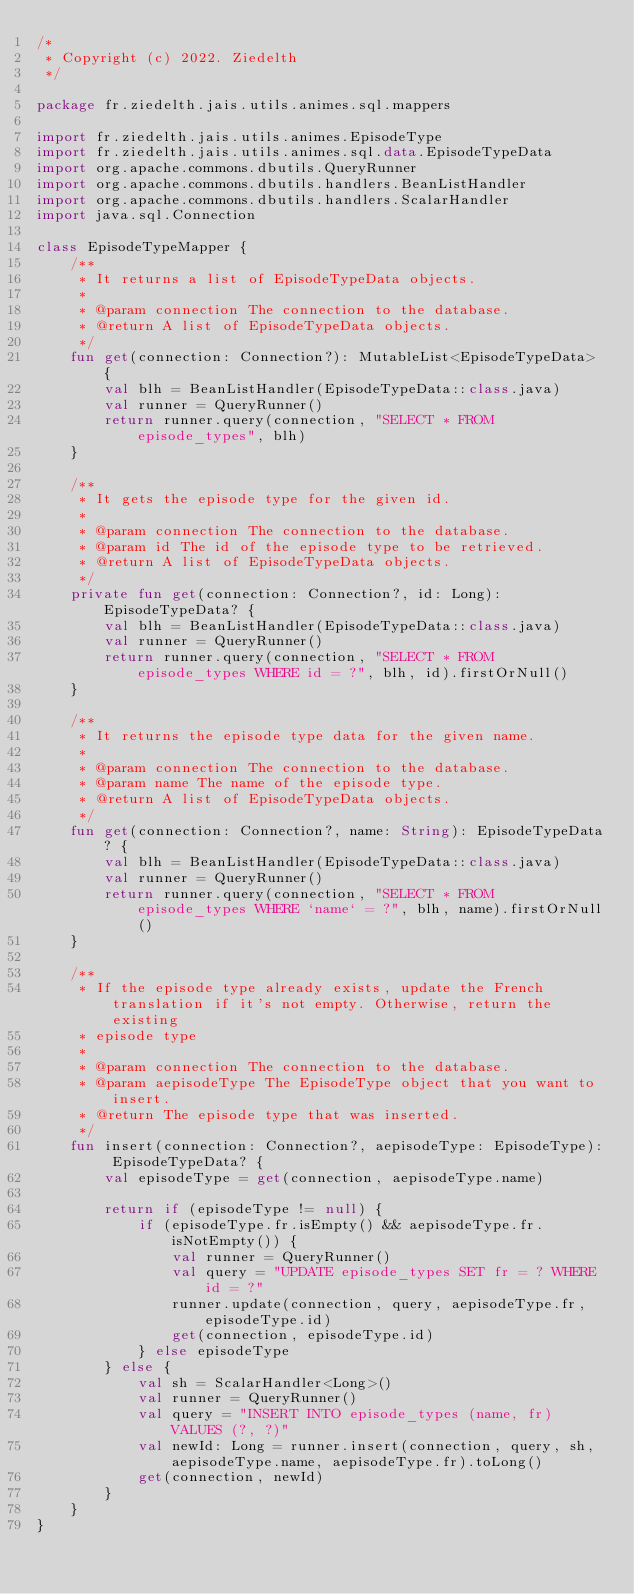Convert code to text. <code><loc_0><loc_0><loc_500><loc_500><_Kotlin_>/*
 * Copyright (c) 2022. Ziedelth
 */

package fr.ziedelth.jais.utils.animes.sql.mappers

import fr.ziedelth.jais.utils.animes.EpisodeType
import fr.ziedelth.jais.utils.animes.sql.data.EpisodeTypeData
import org.apache.commons.dbutils.QueryRunner
import org.apache.commons.dbutils.handlers.BeanListHandler
import org.apache.commons.dbutils.handlers.ScalarHandler
import java.sql.Connection

class EpisodeTypeMapper {
    /**
     * It returns a list of EpisodeTypeData objects.
     *
     * @param connection The connection to the database.
     * @return A list of EpisodeTypeData objects.
     */
    fun get(connection: Connection?): MutableList<EpisodeTypeData> {
        val blh = BeanListHandler(EpisodeTypeData::class.java)
        val runner = QueryRunner()
        return runner.query(connection, "SELECT * FROM episode_types", blh)
    }

    /**
     * It gets the episode type for the given id.
     *
     * @param connection The connection to the database.
     * @param id The id of the episode type to be retrieved.
     * @return A list of EpisodeTypeData objects.
     */
    private fun get(connection: Connection?, id: Long): EpisodeTypeData? {
        val blh = BeanListHandler(EpisodeTypeData::class.java)
        val runner = QueryRunner()
        return runner.query(connection, "SELECT * FROM episode_types WHERE id = ?", blh, id).firstOrNull()
    }

    /**
     * It returns the episode type data for the given name.
     *
     * @param connection The connection to the database.
     * @param name The name of the episode type.
     * @return A list of EpisodeTypeData objects.
     */
    fun get(connection: Connection?, name: String): EpisodeTypeData? {
        val blh = BeanListHandler(EpisodeTypeData::class.java)
        val runner = QueryRunner()
        return runner.query(connection, "SELECT * FROM episode_types WHERE `name` = ?", blh, name).firstOrNull()
    }

    /**
     * If the episode type already exists, update the French translation if it's not empty. Otherwise, return the existing
     * episode type
     *
     * @param connection The connection to the database.
     * @param aepisodeType The EpisodeType object that you want to insert.
     * @return The episode type that was inserted.
     */
    fun insert(connection: Connection?, aepisodeType: EpisodeType): EpisodeTypeData? {
        val episodeType = get(connection, aepisodeType.name)

        return if (episodeType != null) {
            if (episodeType.fr.isEmpty() && aepisodeType.fr.isNotEmpty()) {
                val runner = QueryRunner()
                val query = "UPDATE episode_types SET fr = ? WHERE id = ?"
                runner.update(connection, query, aepisodeType.fr, episodeType.id)
                get(connection, episodeType.id)
            } else episodeType
        } else {
            val sh = ScalarHandler<Long>()
            val runner = QueryRunner()
            val query = "INSERT INTO episode_types (name, fr) VALUES (?, ?)"
            val newId: Long = runner.insert(connection, query, sh, aepisodeType.name, aepisodeType.fr).toLong()
            get(connection, newId)
        }
    }
}</code> 